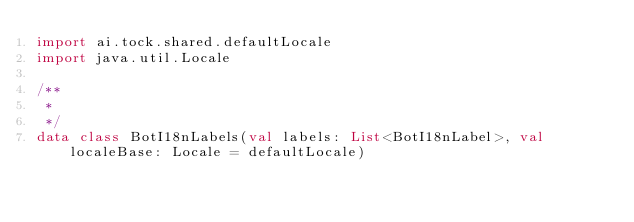Convert code to text. <code><loc_0><loc_0><loc_500><loc_500><_Kotlin_>import ai.tock.shared.defaultLocale
import java.util.Locale

/**
 *
 */
data class BotI18nLabels(val labels: List<BotI18nLabel>, val localeBase: Locale = defaultLocale)</code> 